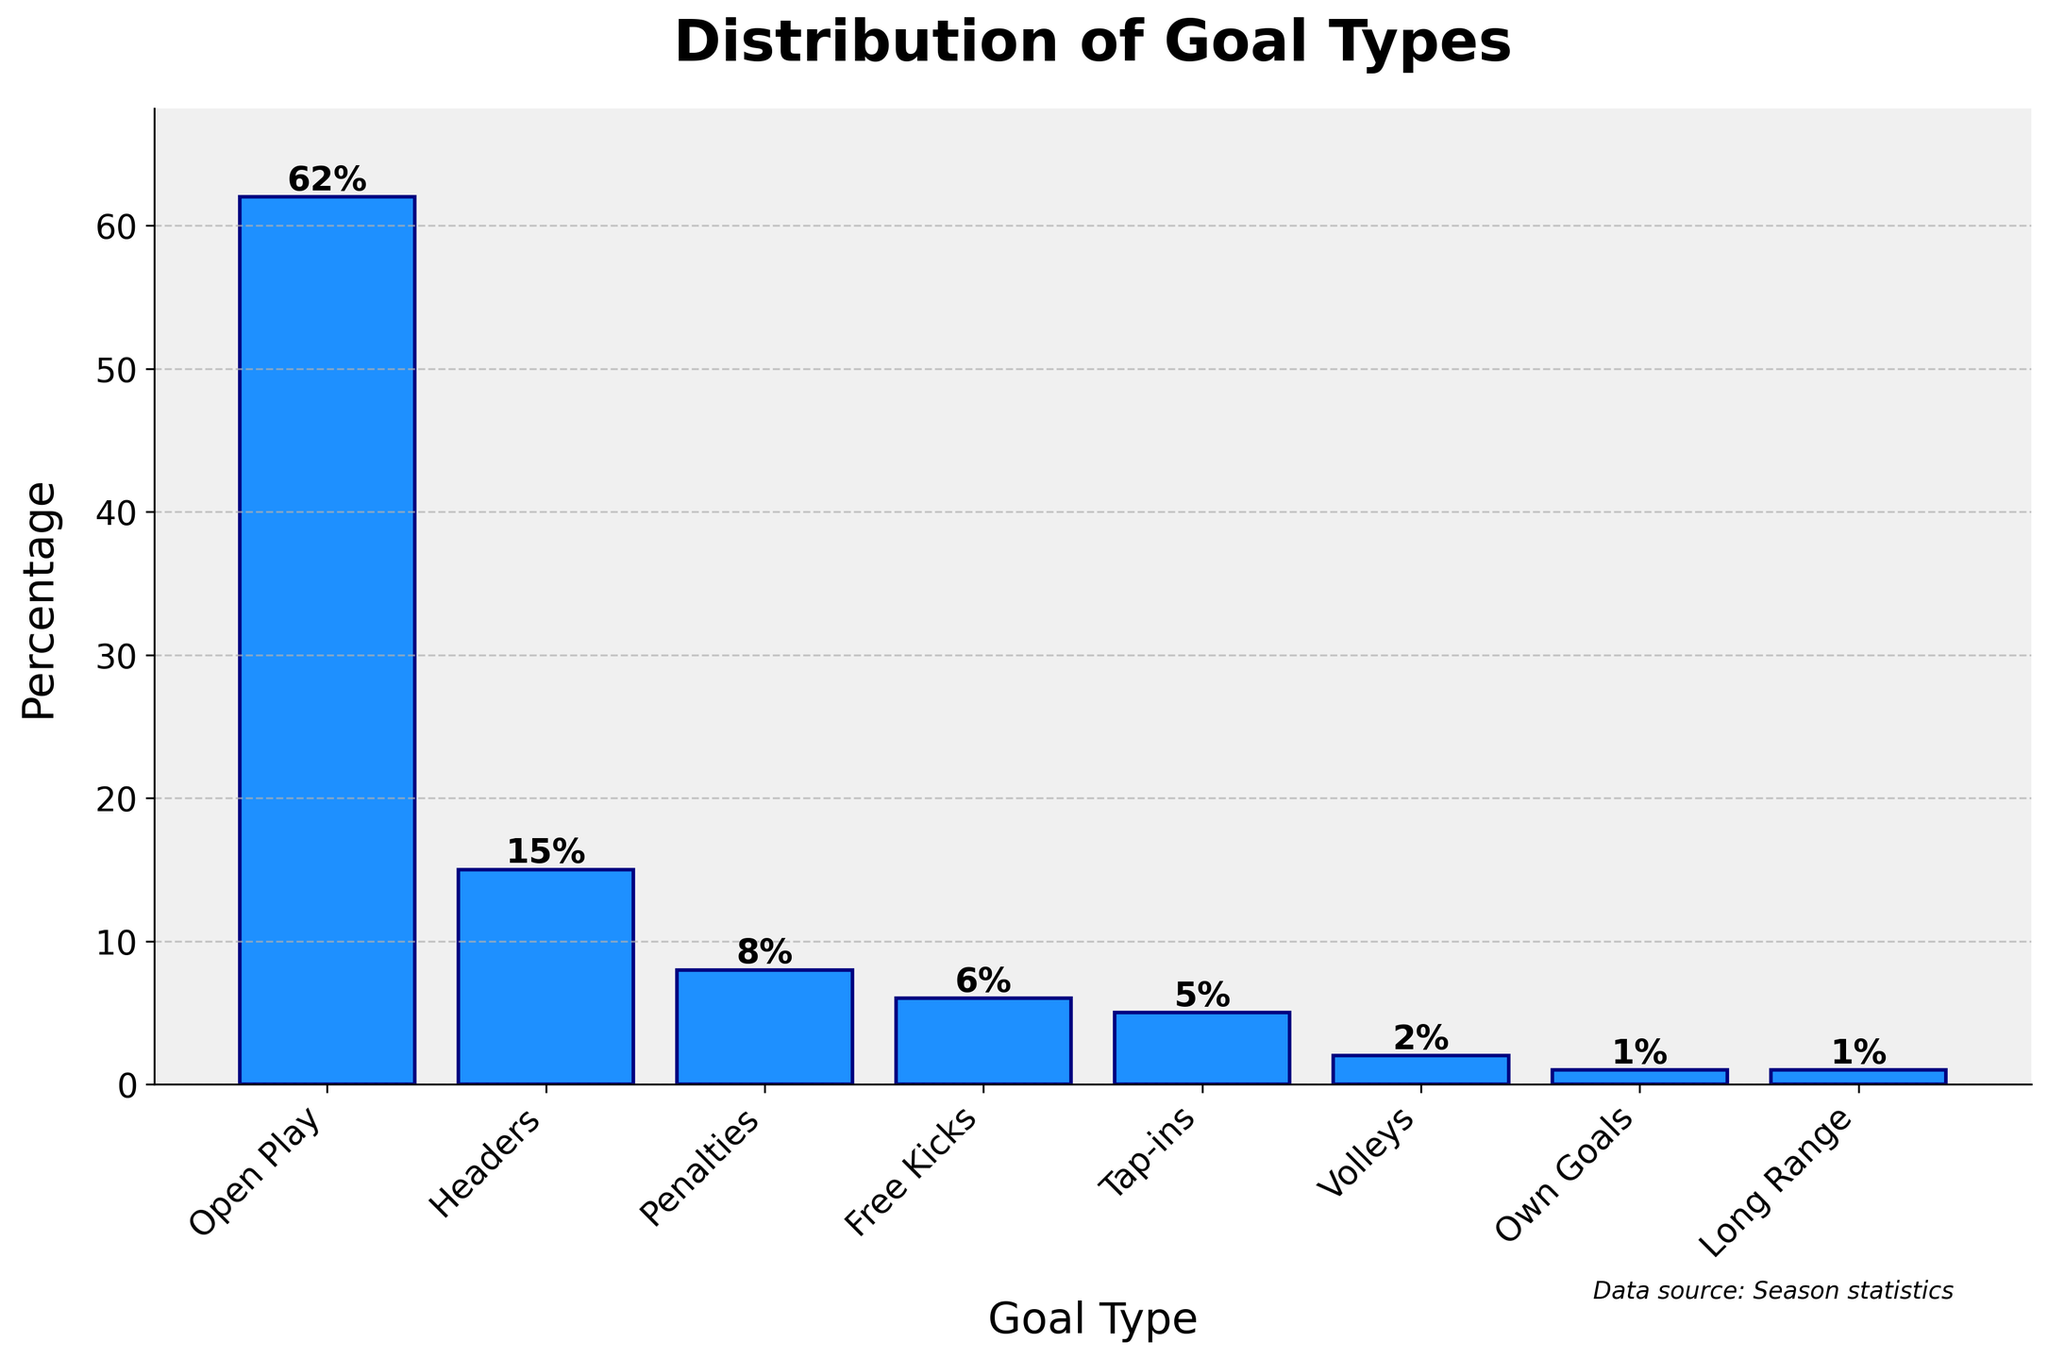What is the most common type of goal scored? The bar representing "Open Play" is the tallest, indicating it has the highest percentage.
Answer: Open Play What percentage of goals are scored from set-pieces (free kicks and penalties)? Add the percentages of free kicks (6%) and penalties (8%): 6% + 8% = 14%.
Answer: 14% How many goal types have a percentage less than 10%? Count the number of goal types with percentages below 10%: headers (15%), penalties (8%), free kicks (6%), tap-ins (5%), volleys (2%), own goals (1%), long range (1%). This gives tap-ins, volleys, own goals, long-range, penalties, and free kicks, leading to six types.
Answer: 6 Which goal type has the second-highest percentage? The second tallest bar represents "Headers" with a percentage of 15%.
Answer: Headers What is the total percentage of goals scored from headers, tap-ins, and volleys combined? Add the percentages for headers (15%), tap-ins (5%), and volleys (2%): 15% + 5% + 2% = 22%.
Answer: 22% By how much does the percentage of open play goals exceed the combined percentage of penalties and free kicks? First, calculate the combined percentage of penalties and free kicks: 8% + 6% = 14%. Then, subtract this from the percentage of open play goals: 62% - 14% = 48%.
Answer: 48% Which goal type has the smallest percentage? The bar representing "Own Goals" and "Long Range" are the smallest, both indicating a percentage of 1%.
Answer: Own Goals, Long Range How does the percentage of headers compare to that of free kicks? The percentage of headers is 15%, which is greater than the percentage of free kicks at 6%.
Answer: Headers are greater What is the percentage contribution of rare goal types (volley, own goals, long-range) to the total? Sum the percentages of volleys (2%), own goals (1%), and long-range (1%): 2% + 1% + 1% = 4%.
Answer: 4% What visual attribute indicates the most frequent goal type? The height of the bar indicates the frequency, with the "Open Play" bar being the tallest.
Answer: Tallest bar 